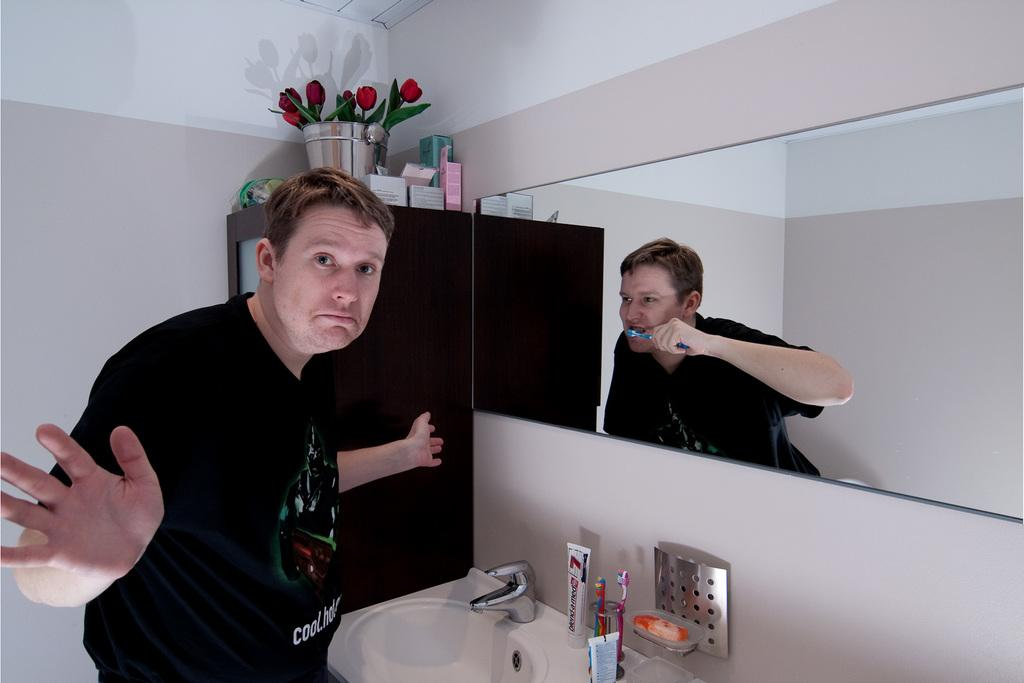Provide a one-sentence caption for the provided image. A man standing in front of a mirror with a tube of defend-a-med in front of him on the counter. 